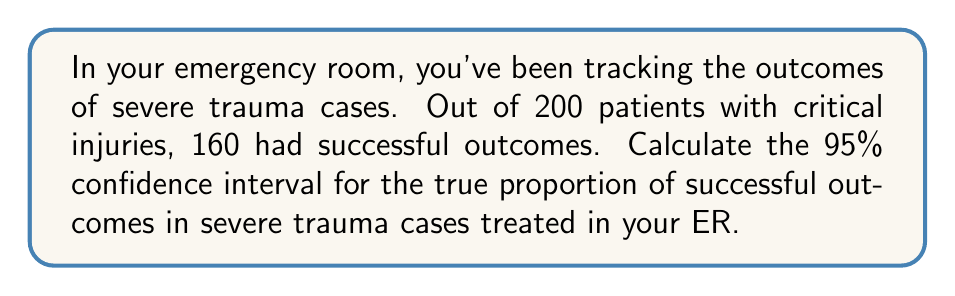Show me your answer to this math problem. To calculate the confidence interval, we'll use the formula for a proportion:

$$ CI = \hat{p} \pm z\sqrt{\frac{\hat{p}(1-\hat{p})}{n}} $$

Where:
$\hat{p}$ = sample proportion
$z$ = z-score for desired confidence level (1.96 for 95% CI)
$n$ = sample size

Step 1: Calculate the sample proportion $\hat{p}$
$\hat{p} = \frac{160}{200} = 0.8$

Step 2: Calculate the standard error
$SE = \sqrt{\frac{\hat{p}(1-\hat{p})}{n}} = \sqrt{\frac{0.8(1-0.8)}{200}} = 0.0283$

Step 3: Calculate the margin of error
$ME = z \times SE = 1.96 \times 0.0283 = 0.0554$

Step 4: Calculate the confidence interval
$CI = 0.8 \pm 0.0554$

Lower bound: $0.8 - 0.0554 = 0.7446$
Upper bound: $0.8 + 0.0554 = 0.8554$

Therefore, the 95% confidence interval is (0.7446, 0.8554).
Answer: (0.7446, 0.8554) 